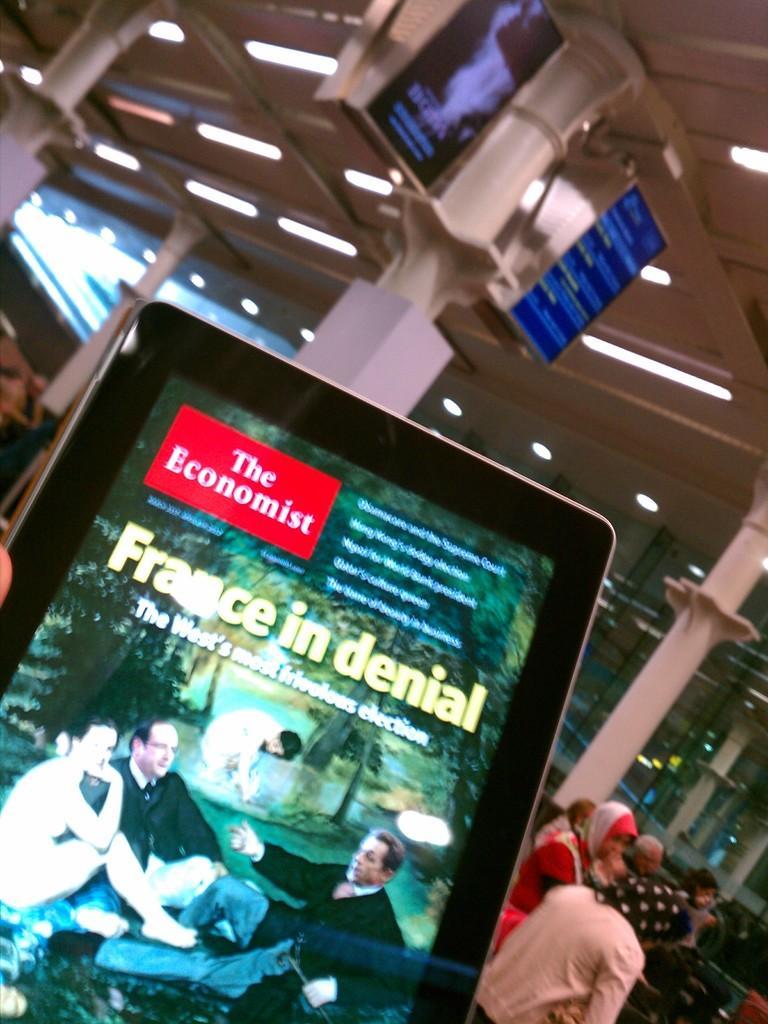Could you give a brief overview of what you see in this image? In the center of the image there is a screen. In the background we can see screens, pillars, persons, chairs and lights. 